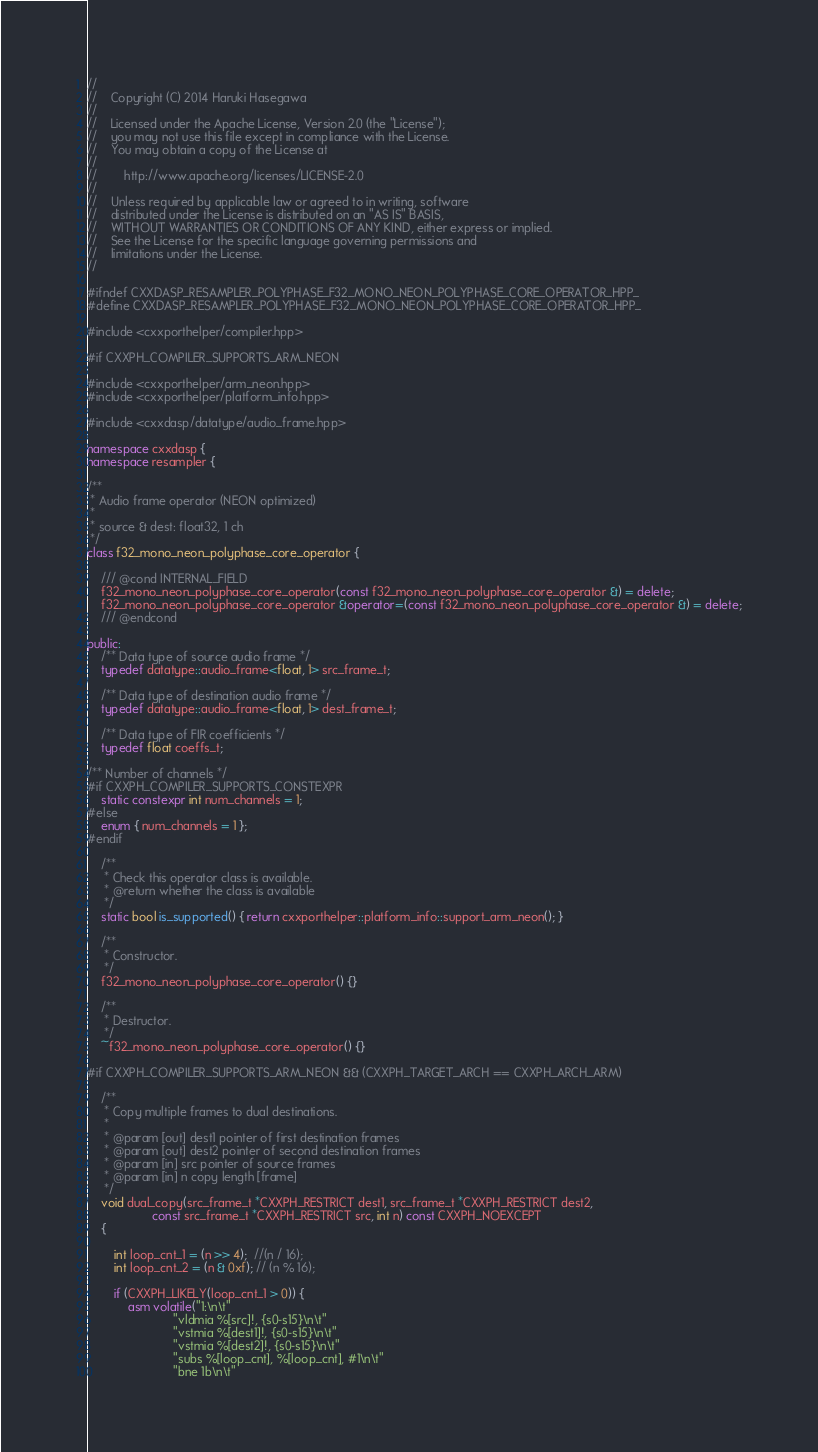Convert code to text. <code><loc_0><loc_0><loc_500><loc_500><_C++_>//
//    Copyright (C) 2014 Haruki Hasegawa
//
//    Licensed under the Apache License, Version 2.0 (the "License");
//    you may not use this file except in compliance with the License.
//    You may obtain a copy of the License at
//
//        http://www.apache.org/licenses/LICENSE-2.0
//
//    Unless required by applicable law or agreed to in writing, software
//    distributed under the License is distributed on an "AS IS" BASIS,
//    WITHOUT WARRANTIES OR CONDITIONS OF ANY KIND, either express or implied.
//    See the License for the specific language governing permissions and
//    limitations under the License.
//

#ifndef CXXDASP_RESAMPLER_POLYPHASE_F32_MONO_NEON_POLYPHASE_CORE_OPERATOR_HPP_
#define CXXDASP_RESAMPLER_POLYPHASE_F32_MONO_NEON_POLYPHASE_CORE_OPERATOR_HPP_

#include <cxxporthelper/compiler.hpp>

#if CXXPH_COMPILER_SUPPORTS_ARM_NEON

#include <cxxporthelper/arm_neon.hpp>
#include <cxxporthelper/platform_info.hpp>

#include <cxxdasp/datatype/audio_frame.hpp>

namespace cxxdasp {
namespace resampler {

/**
 * Audio frame operator (NEON optimized)
 *
 * source & dest: float32, 1 ch
 */
class f32_mono_neon_polyphase_core_operator {

    /// @cond INTERNAL_FIELD
    f32_mono_neon_polyphase_core_operator(const f32_mono_neon_polyphase_core_operator &) = delete;
    f32_mono_neon_polyphase_core_operator &operator=(const f32_mono_neon_polyphase_core_operator &) = delete;
    /// @endcond

public:
    /** Data type of source audio frame */
    typedef datatype::audio_frame<float, 1> src_frame_t;

    /** Data type of destination audio frame */
    typedef datatype::audio_frame<float, 1> dest_frame_t;

    /** Data type of FIR coefficients */
    typedef float coeffs_t;

/** Number of channels */
#if CXXPH_COMPILER_SUPPORTS_CONSTEXPR
    static constexpr int num_channels = 1;
#else
    enum { num_channels = 1 };
#endif

    /**
     * Check this operator class is available.
     * @return whether the class is available
     */
    static bool is_supported() { return cxxporthelper::platform_info::support_arm_neon(); }

    /**
     * Constructor.
     */
    f32_mono_neon_polyphase_core_operator() {}

    /**
     * Destructor.
     */
    ~f32_mono_neon_polyphase_core_operator() {}

#if CXXPH_COMPILER_SUPPORTS_ARM_NEON && (CXXPH_TARGET_ARCH == CXXPH_ARCH_ARM)

    /**
     * Copy multiple frames to dual destinations.
     *
     * @param [out] dest1 pointer of first destination frames
     * @param [out] dest2 pointer of second destination frames
     * @param [in] src pointer of source frames
     * @param [in] n copy length [frame]
     */
    void dual_copy(src_frame_t *CXXPH_RESTRICT dest1, src_frame_t *CXXPH_RESTRICT dest2,
                   const src_frame_t *CXXPH_RESTRICT src, int n) const CXXPH_NOEXCEPT
    {

        int loop_cnt_1 = (n >> 4);  //(n / 16);
        int loop_cnt_2 = (n & 0xf); // (n % 16);

        if (CXXPH_LIKELY(loop_cnt_1 > 0)) {
            asm volatile("1:\n\t"
                         "vldmia %[src]!, {s0-s15}\n\t"
                         "vstmia %[dest1]!, {s0-s15}\n\t"
                         "vstmia %[dest2]!, {s0-s15}\n\t"
                         "subs %[loop_cnt], %[loop_cnt], #1\n\t"
                         "bne 1b\n\t"</code> 